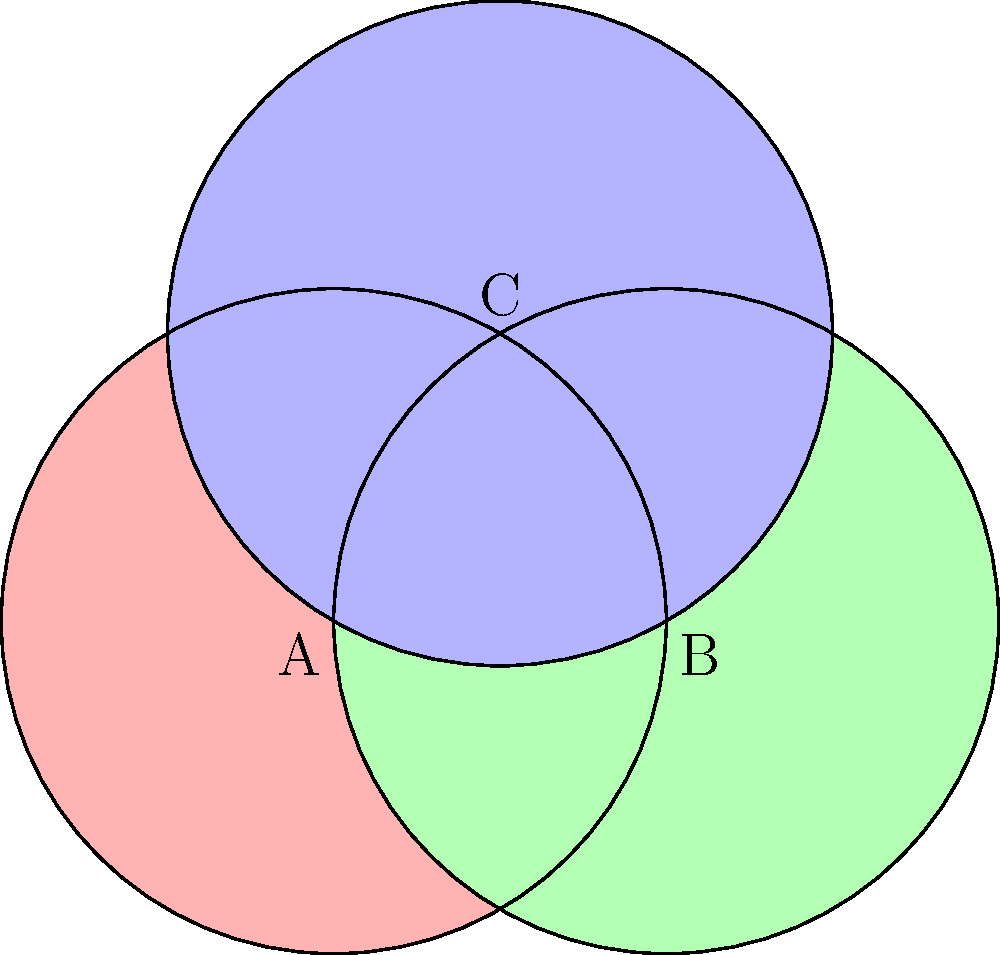In this harmonious Venn diagram, three circles of equal radius intersect to form a balanced composition. If the radius of each circle is 1 unit, what is the area of the central region where all three circles overlap? Express your answer in terms of π. Let's approach this step-by-step, focusing on the beauty and symmetry of the arrangement:

1) First, we recognize that the centers of the three circles form an equilateral triangle. This is a key element of the diagram's balance.

2) The central overlapping region is formed by the intersection of all three circles. Due to the symmetry, this region is composed of three equal circular segments.

3) To find the area of one of these segments, we need to:
   a) Calculate the central angle of the segment
   b) Find the area of the sector formed by this angle
   c) Subtract the area of the triangle formed by the sector

4) The central angle can be found using the formula:
   $\theta = 2 \arccos(\frac{r}{2r}) = 2 \arccos(\frac{1}{2}) = \frac{2\pi}{3}$

5) The area of the sector is:
   $A_{sector} = \frac{1}{2}r^2\theta = \frac{1}{2} \cdot 1^2 \cdot \frac{2\pi}{3} = \frac{\pi}{3}$

6) The area of the triangle is:
   $A_{triangle} = \frac{1}{2} \cdot 1 \cdot \frac{\sqrt{3}}{2} = \frac{\sqrt{3}}{4}$

7) The area of one segment is:
   $A_{segment} = A_{sector} - A_{triangle} = \frac{\pi}{3} - \frac{\sqrt{3}}{4}$

8) The total area of the central region is three times this:
   $A_{total} = 3(\frac{\pi}{3} - \frac{\sqrt{3}}{4}) = \pi - \frac{3\sqrt{3}}{4}$

This result beautifully combines the transcendental π with the algebraic $\sqrt{3}$, reflecting the harmony between the circular and triangular elements in the diagram.
Answer: $\pi - \frac{3\sqrt{3}}{4}$ 